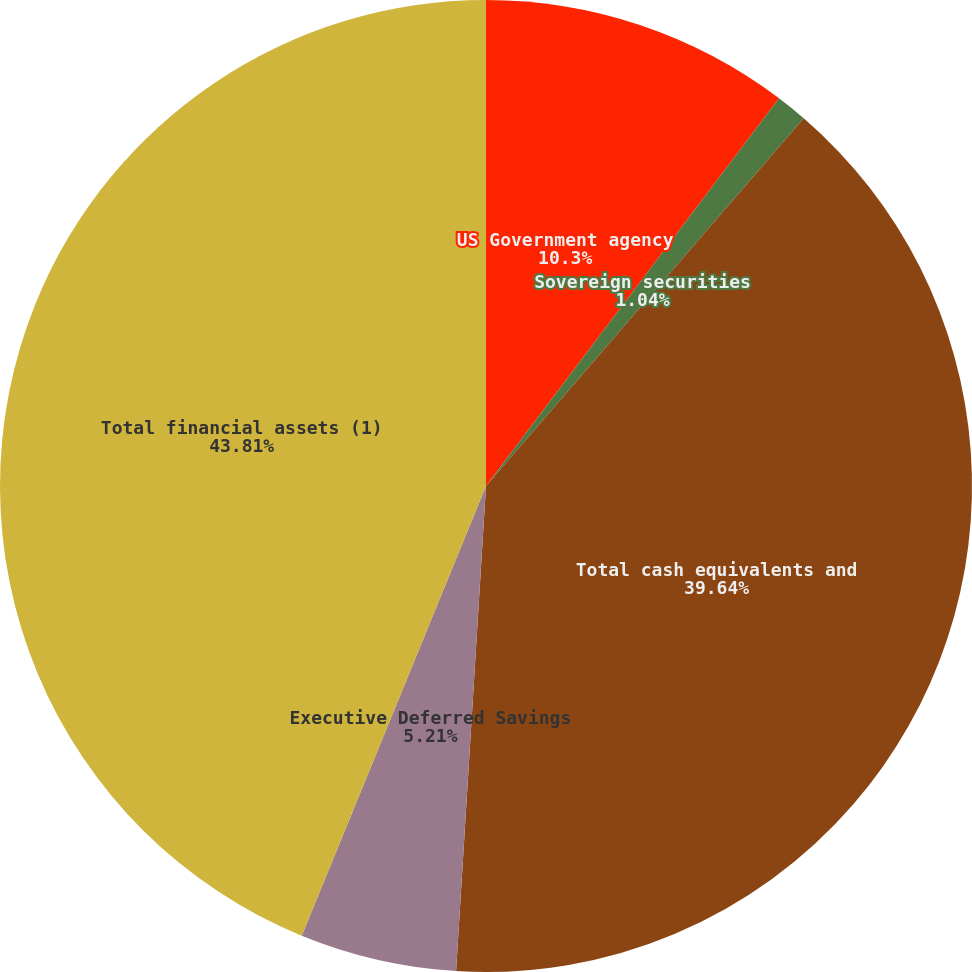<chart> <loc_0><loc_0><loc_500><loc_500><pie_chart><fcel>US Government agency<fcel>Sovereign securities<fcel>Total cash equivalents and<fcel>Executive Deferred Savings<fcel>Total financial assets (1)<nl><fcel>10.3%<fcel>1.04%<fcel>39.64%<fcel>5.21%<fcel>43.81%<nl></chart> 